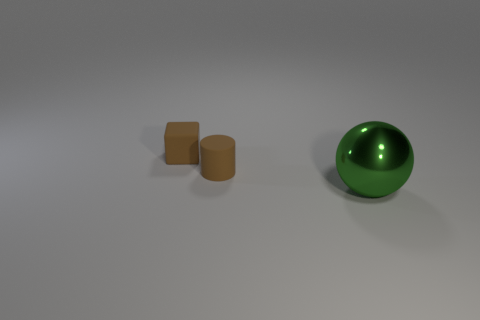Add 2 brown cubes. How many objects exist? 5 Subtract 1 balls. How many balls are left? 0 Subtract all balls. How many objects are left? 2 Subtract all blue balls. Subtract all gray cylinders. How many balls are left? 1 Subtract all green balls. How many cyan cylinders are left? 0 Subtract all blue rubber cylinders. Subtract all green metallic things. How many objects are left? 2 Add 1 big metallic objects. How many big metallic objects are left? 2 Add 2 small purple blocks. How many small purple blocks exist? 2 Subtract 0 red cubes. How many objects are left? 3 